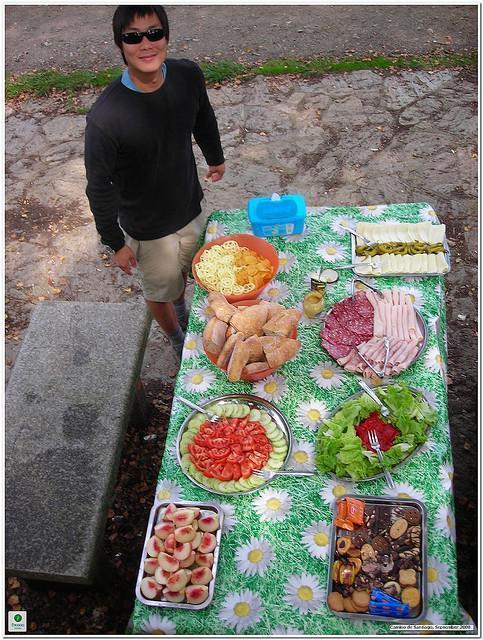How many people are seated?
Give a very brief answer. 0. How many people is coming to this picnic?
Give a very brief answer. 1. How many bowls are there?
Give a very brief answer. 2. How many vases are there?
Give a very brief answer. 0. 